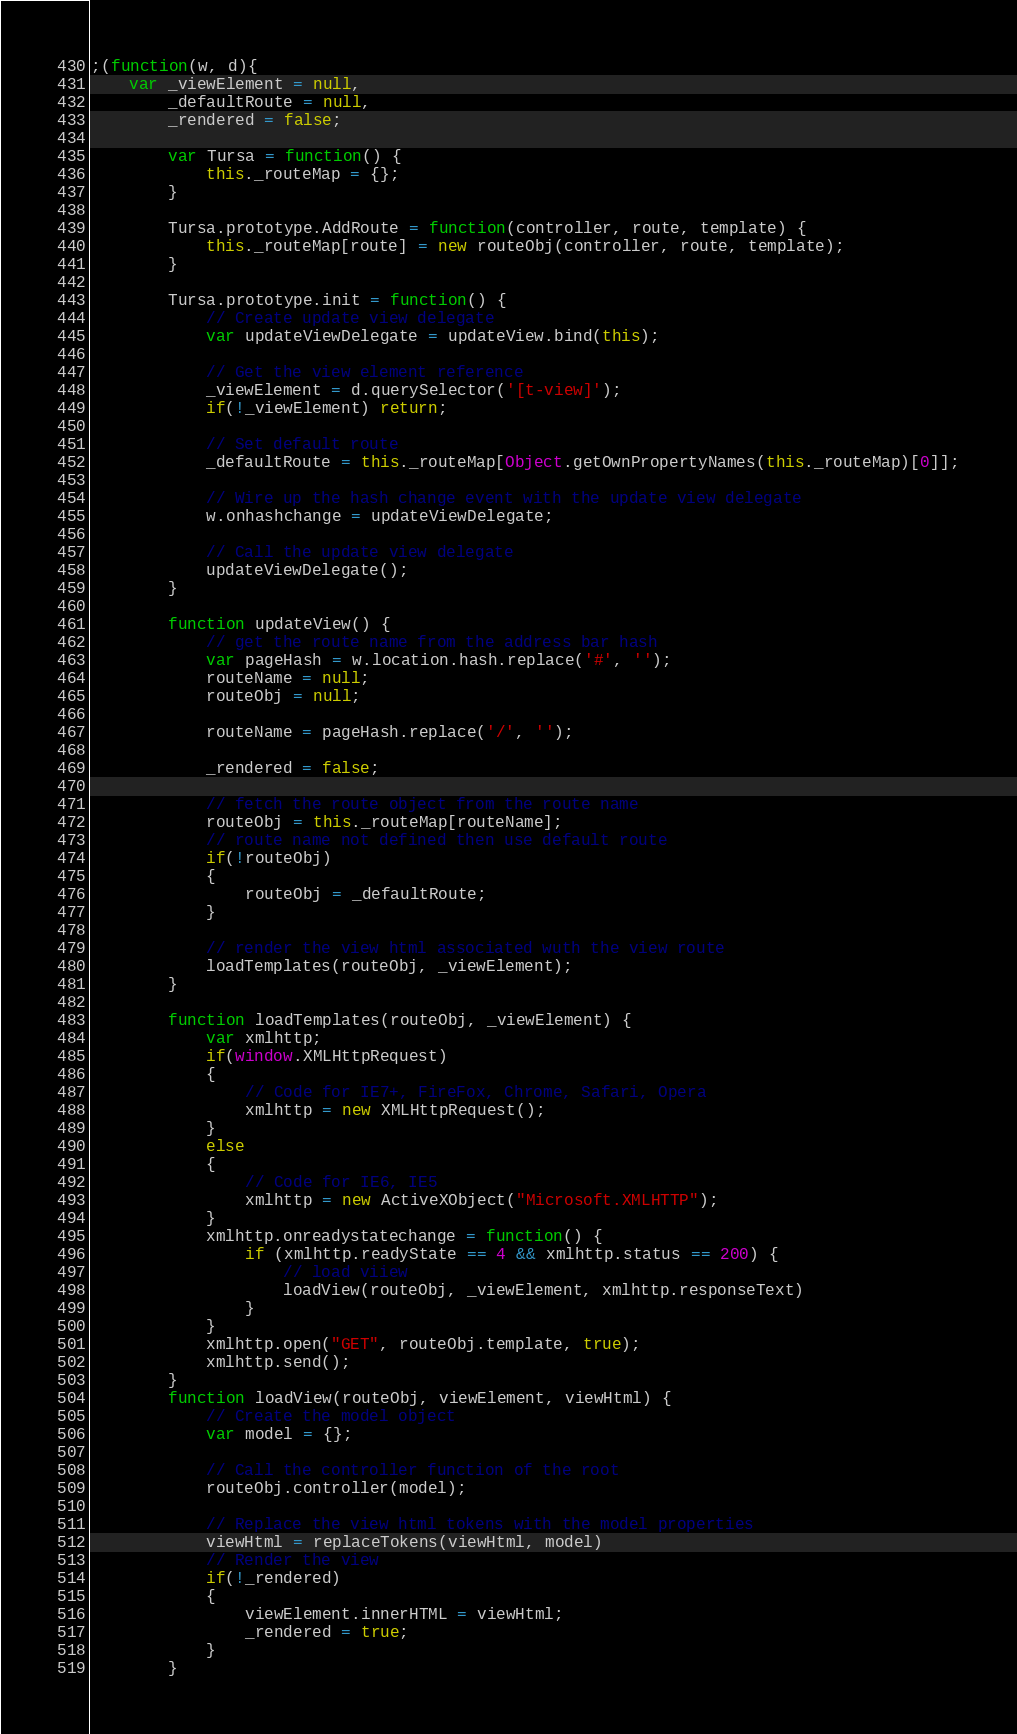<code> <loc_0><loc_0><loc_500><loc_500><_JavaScript_>;(function(w, d){
    var _viewElement = null,
        _defaultRoute = null,
        _rendered = false;

        var Tursa = function() {
            this._routeMap = {};
        }

        Tursa.prototype.AddRoute = function(controller, route, template) {
            this._routeMap[route] = new routeObj(controller, route, template);
        }

        Tursa.prototype.init = function() {
            // Create update view delegate
            var updateViewDelegate = updateView.bind(this);
            
            // Get the view element reference
            _viewElement = d.querySelector('[t-view]');
            if(!_viewElement) return;

            // Set default route 
            _defaultRoute = this._routeMap[Object.getOwnPropertyNames(this._routeMap)[0]];

            // Wire up the hash change event with the update view delegate
            w.onhashchange = updateViewDelegate;

            // Call the update view delegate
            updateViewDelegate();
        }
        
        function updateView() {
            // get the route name from the address bar hash
            var pageHash = w.location.hash.replace('#', '');
            routeName = null;
            routeObj = null;

            routeName = pageHash.replace('/', '');

            _rendered = false;

            // fetch the route object from the route name
            routeObj = this._routeMap[routeName];
            // route name not defined then use default route
            if(!routeObj)
            {
                routeObj = _defaultRoute;
            }

            // render the view html associated wuth the view route
            loadTemplates(routeObj, _viewElement);
        }   

        function loadTemplates(routeObj, _viewElement) {
            var xmlhttp;
            if(window.XMLHttpRequest)
            {
                // Code for IE7+, FireFox, Chrome, Safari, Opera
                xmlhttp = new XMLHttpRequest();
            }
            else
            {   
                // Code for IE6, IE5
                xmlhttp = new ActiveXObject("Microsoft.XMLHTTP");
            }
            xmlhttp.onreadystatechange = function() {
                if (xmlhttp.readyState == 4 && xmlhttp.status == 200) {
                    // load viiew
                    loadView(routeObj, _viewElement, xmlhttp.responseText)
                }
            }
            xmlhttp.open("GET", routeObj.template, true);
            xmlhttp.send();
        }
        function loadView(routeObj, viewElement, viewHtml) {
            // Create the model object
            var model = {};

            // Call the controller function of the root
            routeObj.controller(model);

            // Replace the view html tokens with the model properties
            viewHtml = replaceTokens(viewHtml, model)
            // Render the view
            if(!_rendered)
            {
                viewElement.innerHTML = viewHtml;
                _rendered = true;
            }
        }</code> 